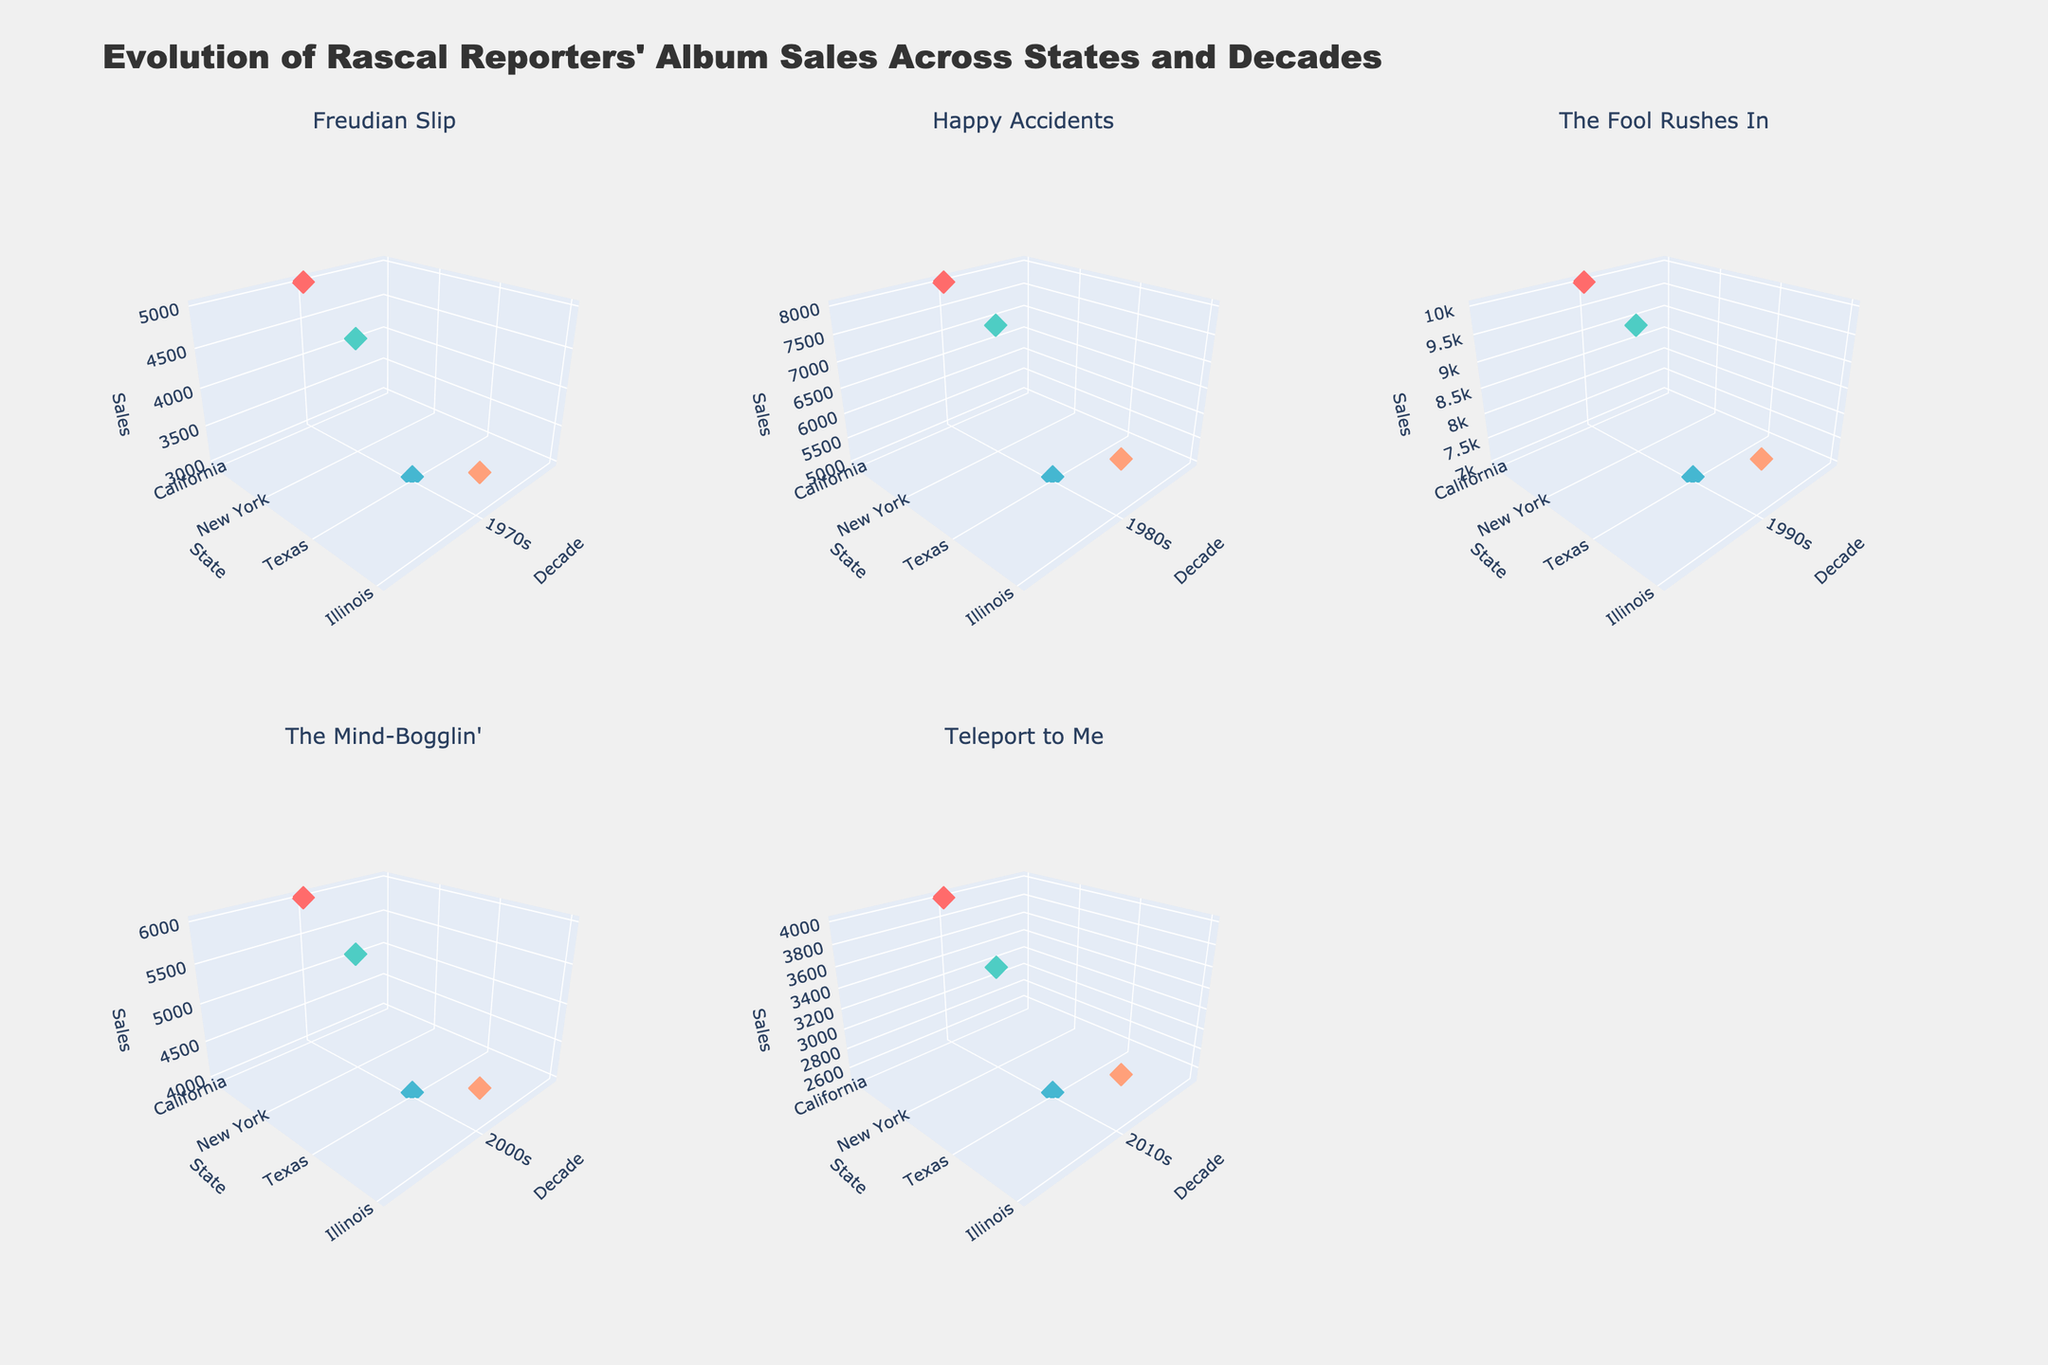What's the title of the figure? The title is often prominently displayed at the top of the figure. In this case, we know from the provided code that the title is "Evolution of Rascal Reporters' Album Sales Across States and Decades".
Answer: Evolution of Rascal Reporters' Album Sales Across States and Decades How many subplots are there in the figure? The code creates subplots with two rows and three columns, resulting in a total of six subplots. Each subplot corresponds to one of Rascal Reporters' albums.
Answer: Six Which state had the highest sales for the album "Happy Accidents" in the 1980s? For the "Happy Accidents" album in the 1980s, the data shows that California had the highest sales with 8000 units. This can be inferred from the subplot for "Happy Accidents".
Answer: California Compare the sales trend for "Freudian Slip" across the states in the 1970s. Which state had the highest sales, and which had the lowest? Observing the subplot for "Freudian Slip" in the 1970s, California had the highest sales with 5000 units, while Texas had the lowest sales with 3000 units.
Answer: Highest: California; Lowest: Texas What is the trend in album sales for "The Fool Rushes In" across different decades in California? The subplot for "The Fool Rushes In" shows the sales for California increase from the 1980s (8000 units) to the 1990s (10000 units), and then decline in the 2000s to 6000 units.
Answer: Increased until 1990s, then declined In which decade did Illinois see the peak sales for all albums combined? For each album, sum up the sales figures in Illinois per decade. The 1990s had the highest total with 8000 units of "The Fool Rushes In".
Answer: 1990s How do the sales figures for "The Mind-Bogglin'" in Texas compare to those in New York in the 2000s? Referring to the subplot for "The Mind-Bogglin'", Texas had sales of 4000 units while New York had 5500 units. Therefore, New York's sales were higher.
Answer: New York higher than Texas What's the overall trend in album sales for New York from the 1970s to the 2010s? By examining the subplots, in New York, sales started at 4500 for "Freudian Slip" in the 1970s, rose to 7500 for "Happy Accidents" in the 1980s, peaked at 9500 for "The Fool Rushes In" in the 1990s, then declined to 5500 for "The Mind-Bogglin'" in the 2000s, and further dropped to 3500 for "Teleport to Me" in the 2010s.
Answer: Initially rose to peak in 1990s, then declined Which album had the least variation in sales across the states during its release decade? The figure shows "Freudian Slip" had least variation in 1970s with sales ranging from 3000 to 5000, a range of 2000. This is smaller compared to other albums which have ranges greater than 2000 across states.
Answer: Freudian Slip 